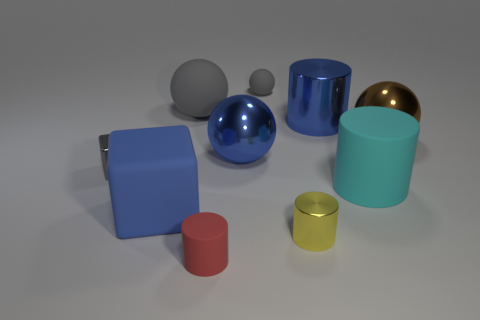Subtract all green cylinders. Subtract all yellow spheres. How many cylinders are left? 4 Subtract all blocks. How many objects are left? 8 Add 2 small yellow metal cylinders. How many small yellow metal cylinders exist? 3 Subtract 1 red cylinders. How many objects are left? 9 Subtract all big brown things. Subtract all tiny yellow things. How many objects are left? 8 Add 3 big blue metallic cylinders. How many big blue metallic cylinders are left? 4 